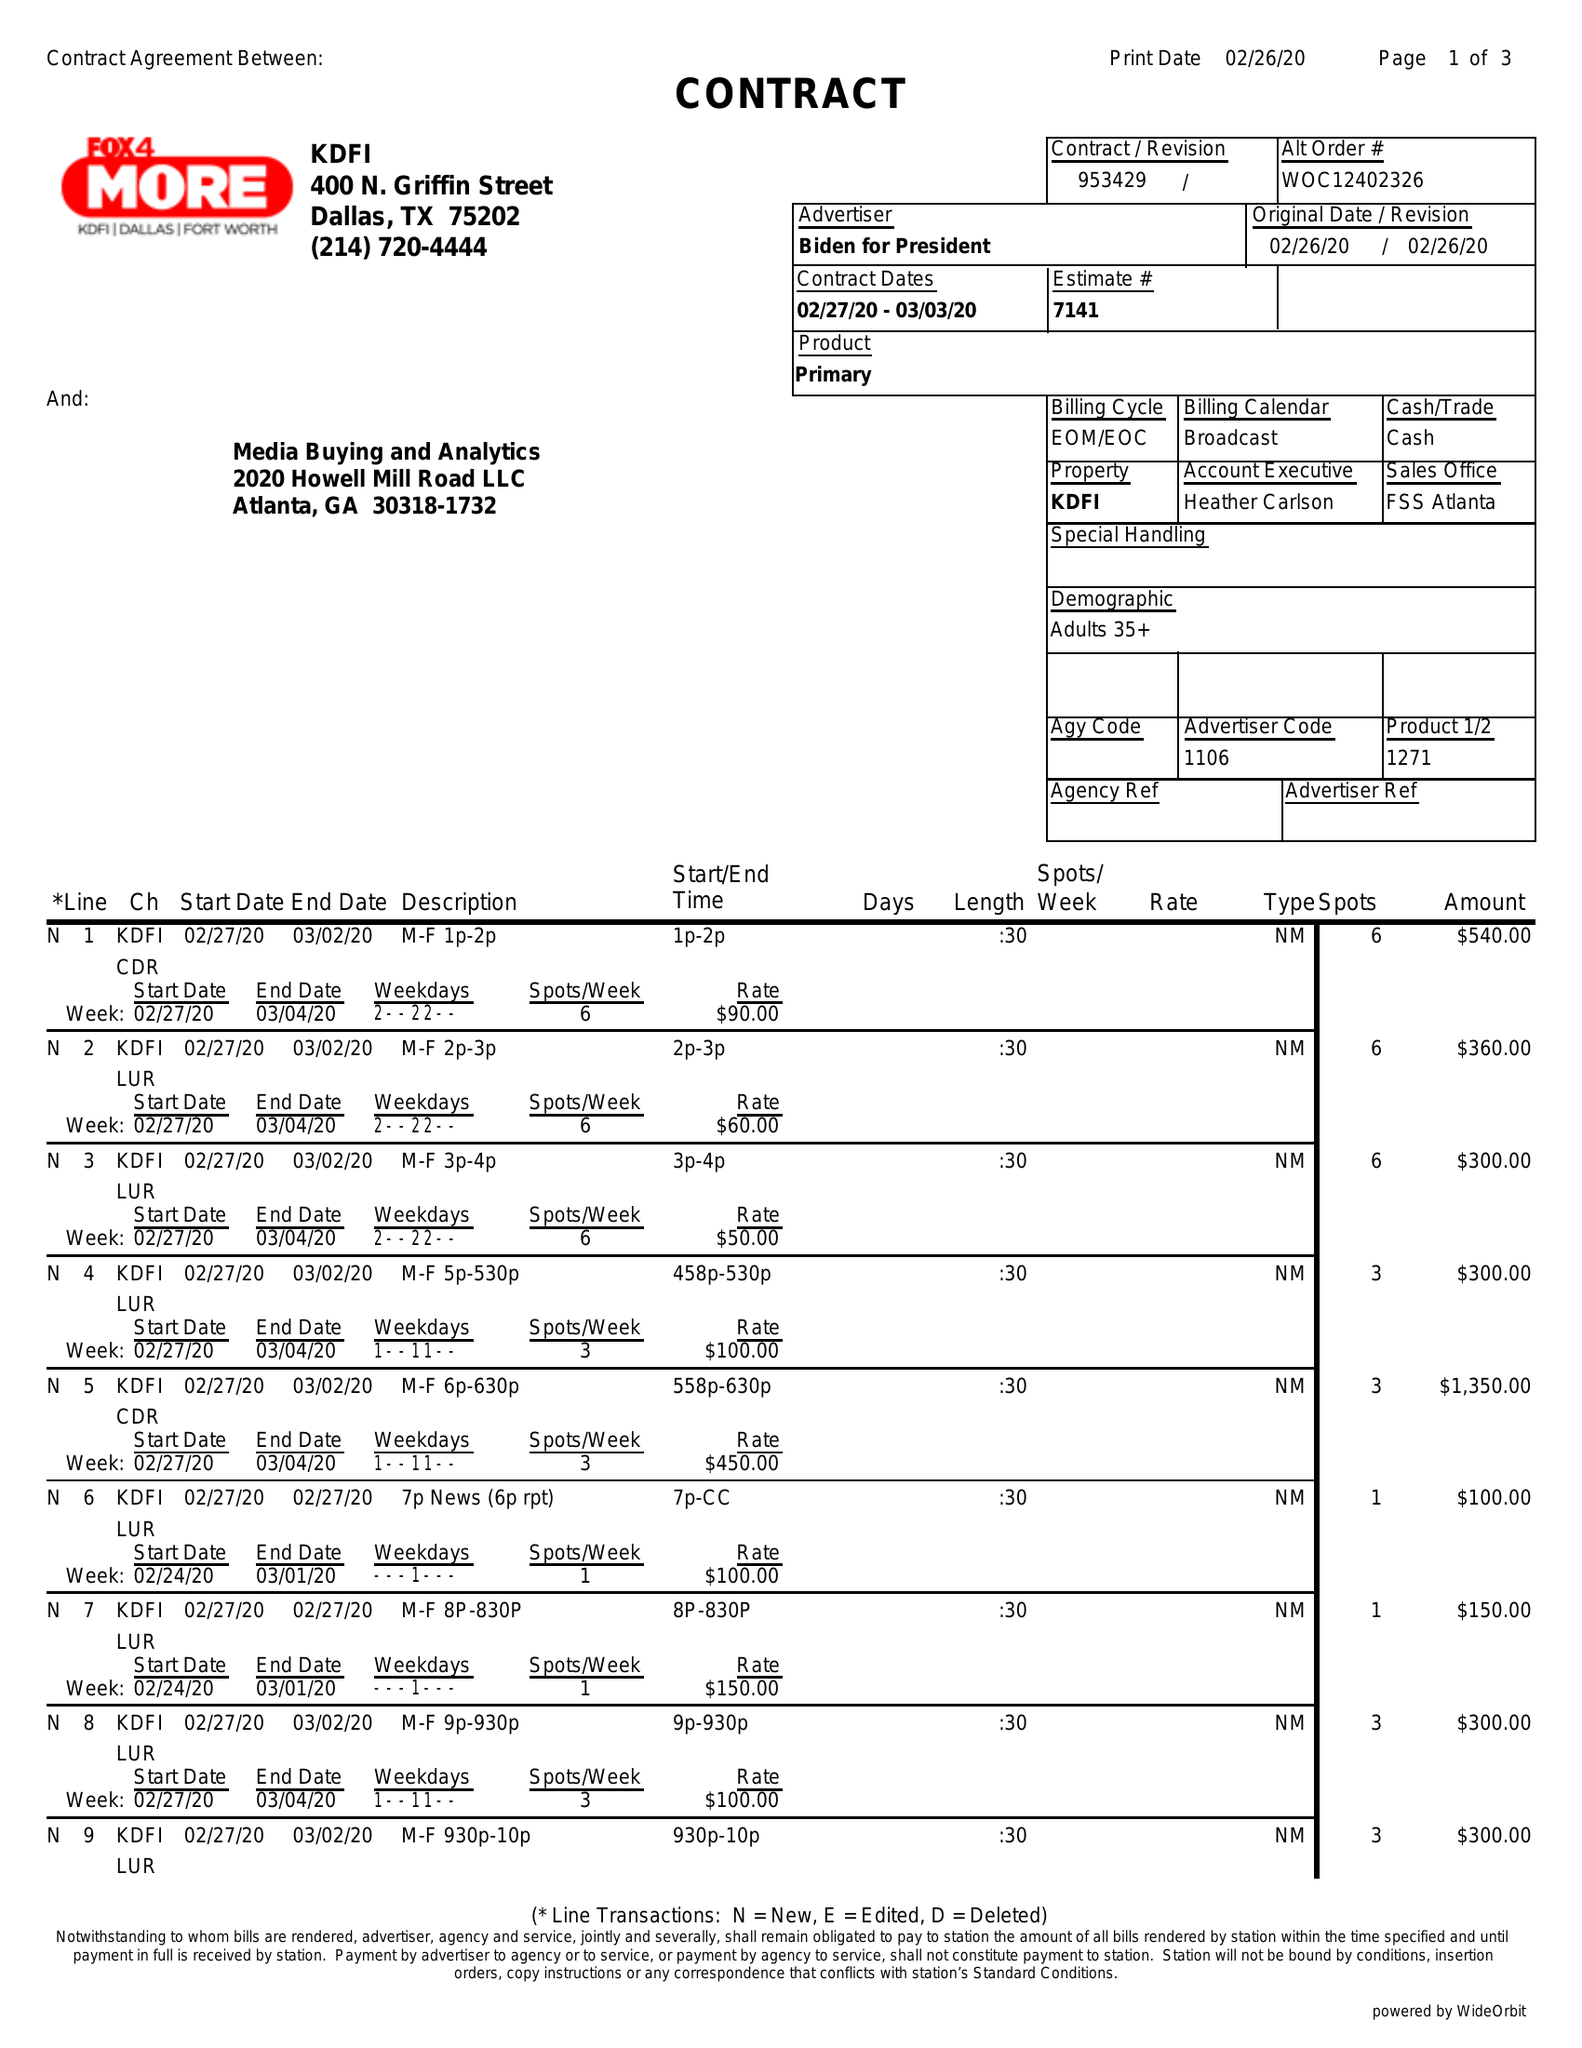What is the value for the contract_num?
Answer the question using a single word or phrase. 953429 